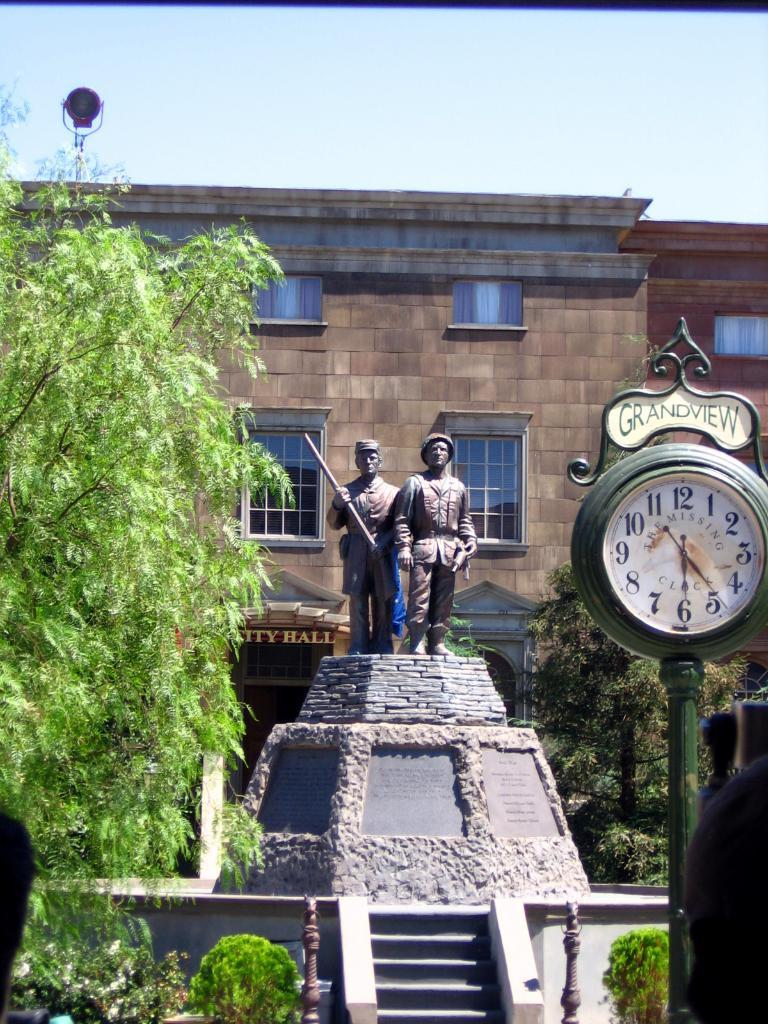Provide a one-sentence caption for the provided image. The Grandview clock in front of a raised statue of two soldiers which is in front of the City Hall building. 